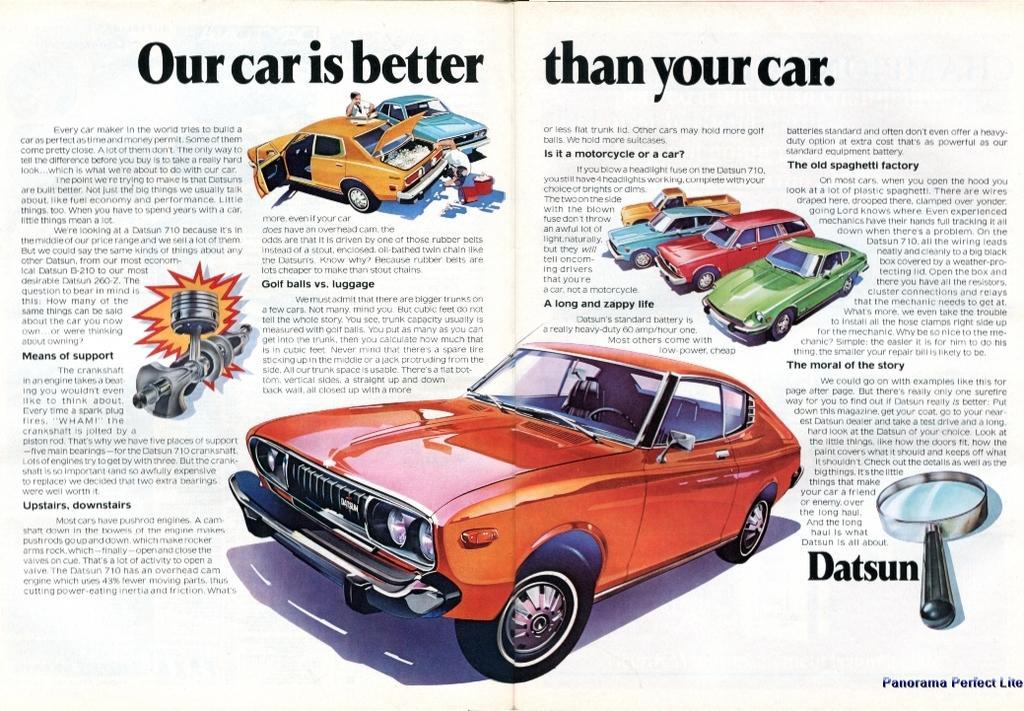Describe this image in one or two sentences. This image consists of a poster with text and a few images of cars on it. 